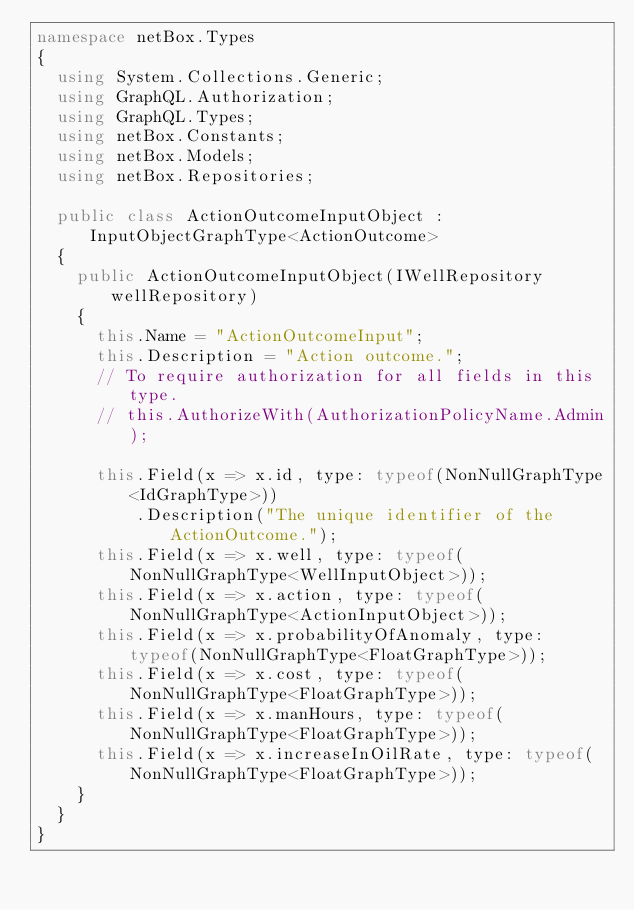<code> <loc_0><loc_0><loc_500><loc_500><_C#_>namespace netBox.Types
{
  using System.Collections.Generic;
  using GraphQL.Authorization;
  using GraphQL.Types;
  using netBox.Constants;
  using netBox.Models;
  using netBox.Repositories;

  public class ActionOutcomeInputObject : InputObjectGraphType<ActionOutcome>
  {
    public ActionOutcomeInputObject(IWellRepository wellRepository)
    {
      this.Name = "ActionOutcomeInput";
      this.Description = "Action outcome.";
      // To require authorization for all fields in this type.
      // this.AuthorizeWith(AuthorizationPolicyName.Admin);

      this.Field(x => x.id, type: typeof(NonNullGraphType<IdGraphType>))
          .Description("The unique identifier of the ActionOutcome.");
      this.Field(x => x.well, type: typeof(NonNullGraphType<WellInputObject>));
      this.Field(x => x.action, type: typeof(NonNullGraphType<ActionInputObject>));
      this.Field(x => x.probabilityOfAnomaly, type: typeof(NonNullGraphType<FloatGraphType>));
      this.Field(x => x.cost, type: typeof(NonNullGraphType<FloatGraphType>));
      this.Field(x => x.manHours, type: typeof(NonNullGraphType<FloatGraphType>));
      this.Field(x => x.increaseInOilRate, type: typeof(NonNullGraphType<FloatGraphType>));
    }
  }
}
</code> 